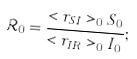Convert formula to latex. <formula><loc_0><loc_0><loc_500><loc_500>\mathcal { R } _ { 0 } = \frac { < r _ { S I } > _ { 0 } S _ { 0 } } { < r _ { I R } > _ { 0 } I _ { 0 } } ;</formula> 